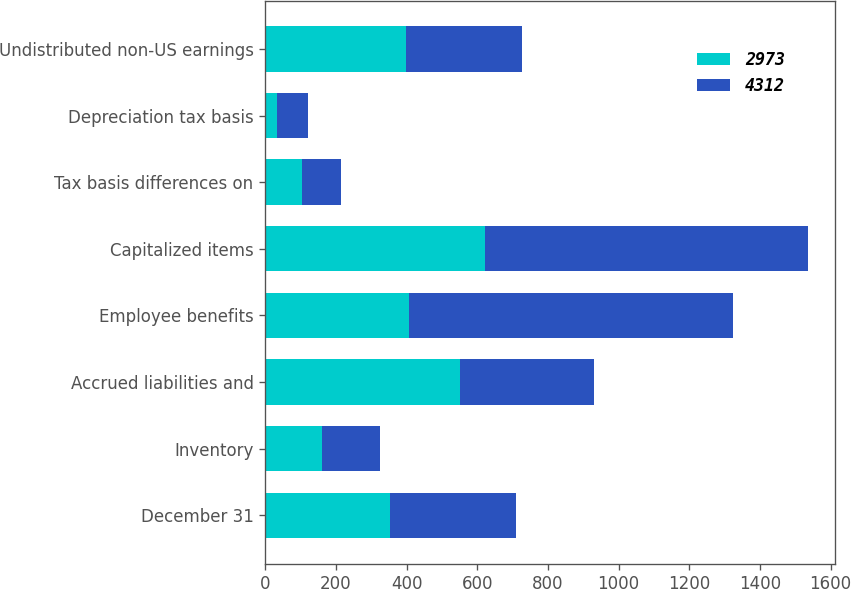<chart> <loc_0><loc_0><loc_500><loc_500><stacked_bar_chart><ecel><fcel>December 31<fcel>Inventory<fcel>Accrued liabilities and<fcel>Employee benefits<fcel>Capitalized items<fcel>Tax basis differences on<fcel>Depreciation tax basis<fcel>Undistributed non-US earnings<nl><fcel>2973<fcel>354.5<fcel>162<fcel>551<fcel>408<fcel>621<fcel>105<fcel>33<fcel>397<nl><fcel>4312<fcel>354.5<fcel>163<fcel>380<fcel>915<fcel>915<fcel>110<fcel>89<fcel>329<nl></chart> 